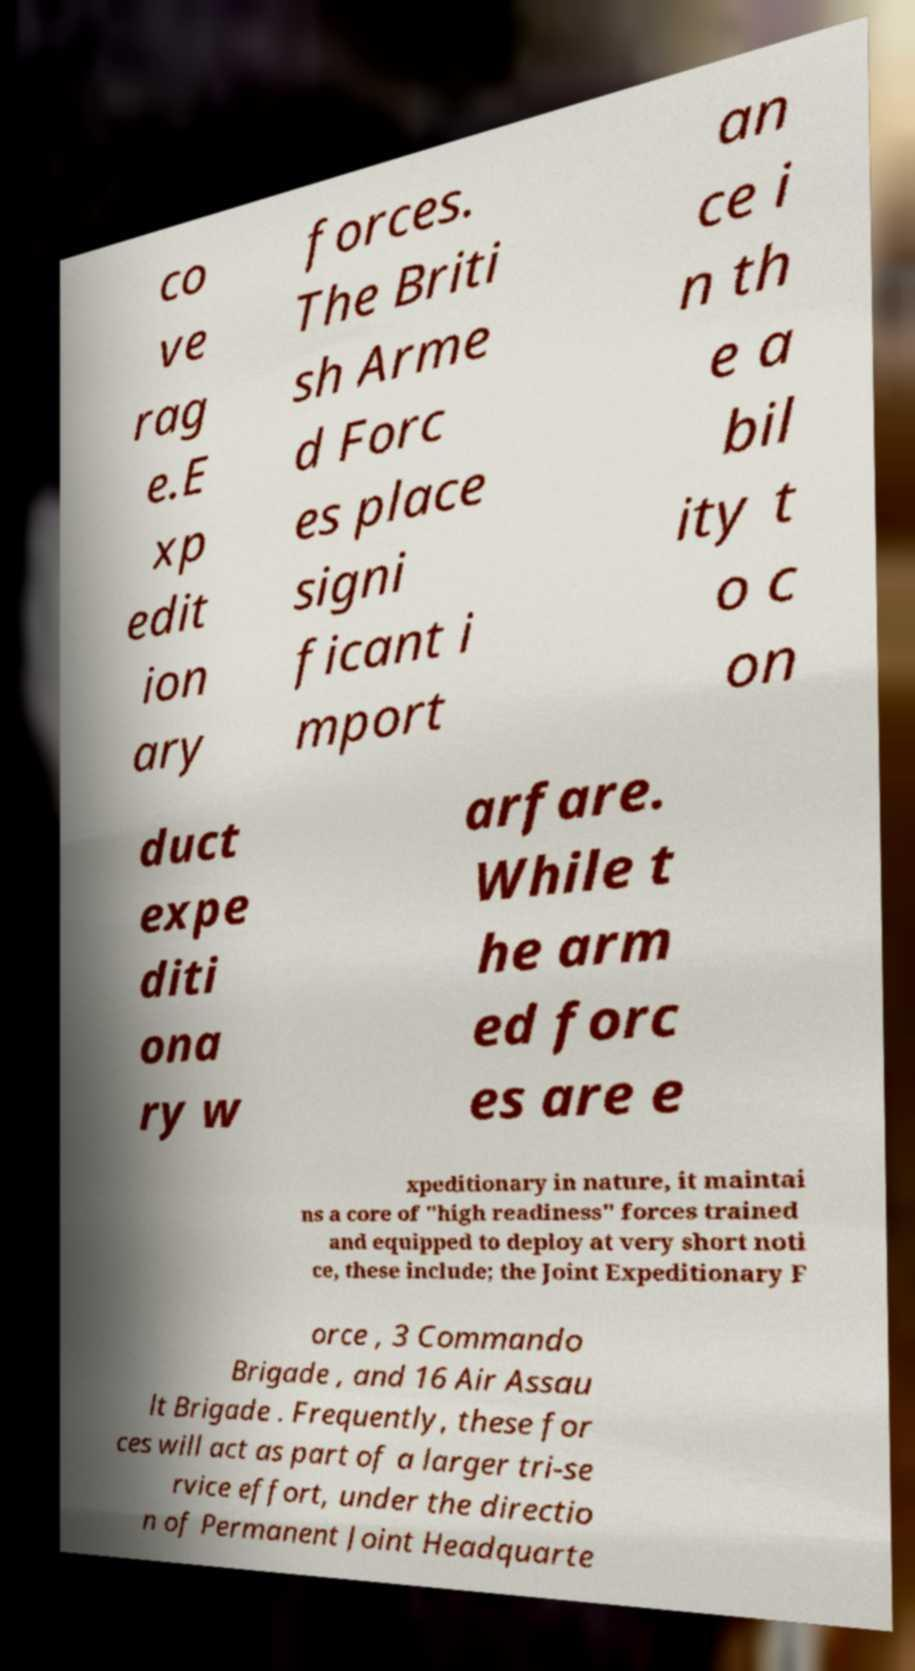Can you read and provide the text displayed in the image?This photo seems to have some interesting text. Can you extract and type it out for me? co ve rag e.E xp edit ion ary forces. The Briti sh Arme d Forc es place signi ficant i mport an ce i n th e a bil ity t o c on duct expe diti ona ry w arfare. While t he arm ed forc es are e xpeditionary in nature, it maintai ns a core of "high readiness" forces trained and equipped to deploy at very short noti ce, these include; the Joint Expeditionary F orce , 3 Commando Brigade , and 16 Air Assau lt Brigade . Frequently, these for ces will act as part of a larger tri-se rvice effort, under the directio n of Permanent Joint Headquarte 